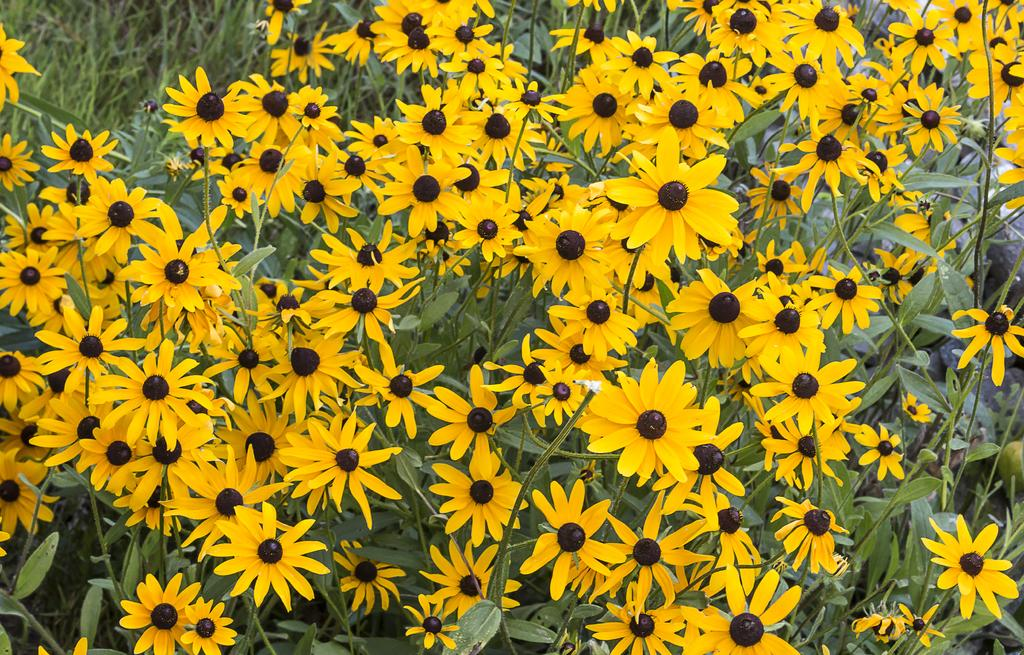What color are the flowers in the image? The flowers in the image are yellow. What else can be seen in the image besides the flowers? There are leaves in the image. How many quarters can be seen in the image? There are no quarters present in the image. Can you describe any actions being performed by the flowers in the image? The flowers in the image are stationary and not performing any actions. 